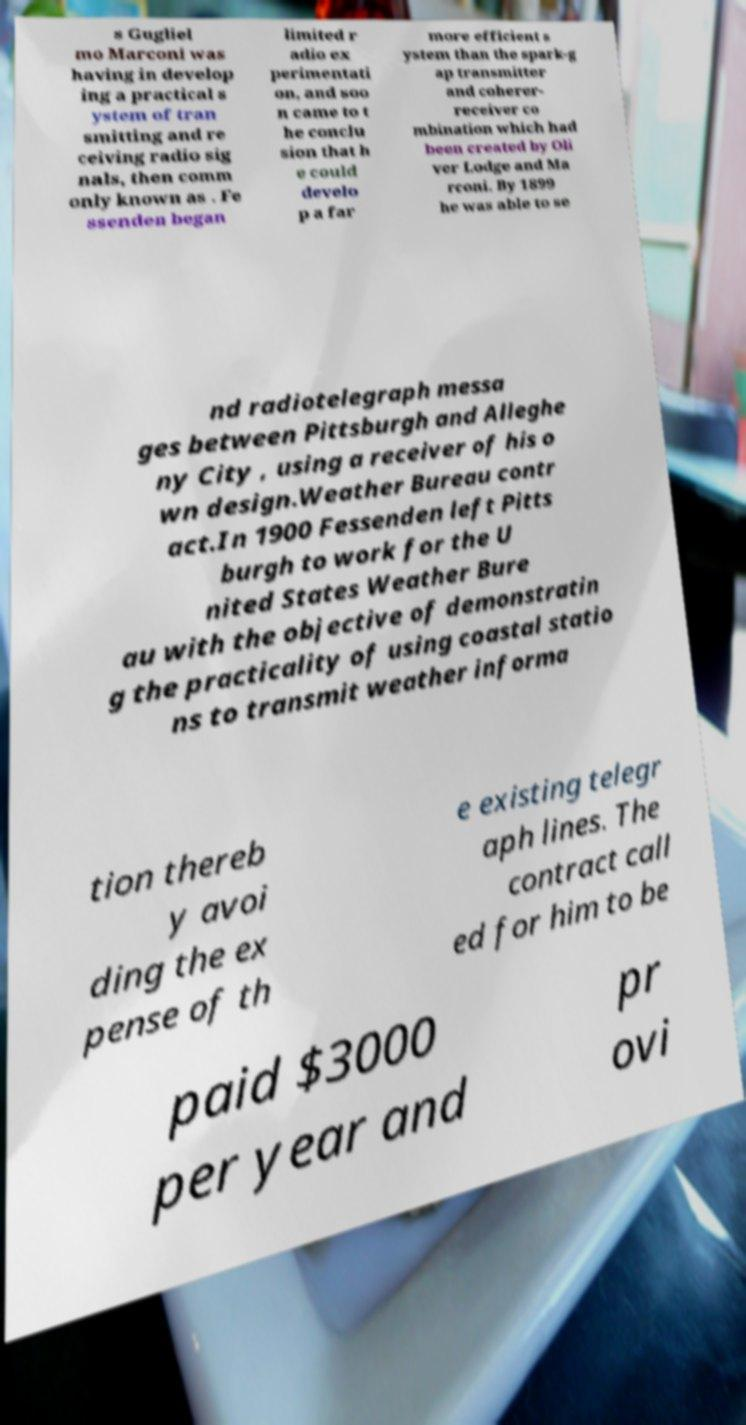I need the written content from this picture converted into text. Can you do that? s Gugliel mo Marconi was having in develop ing a practical s ystem of tran smitting and re ceiving radio sig nals, then comm only known as . Fe ssenden began limited r adio ex perimentati on, and soo n came to t he conclu sion that h e could develo p a far more efficient s ystem than the spark-g ap transmitter and coherer- receiver co mbination which had been created by Oli ver Lodge and Ma rconi. By 1899 he was able to se nd radiotelegraph messa ges between Pittsburgh and Alleghe ny City , using a receiver of his o wn design.Weather Bureau contr act.In 1900 Fessenden left Pitts burgh to work for the U nited States Weather Bure au with the objective of demonstratin g the practicality of using coastal statio ns to transmit weather informa tion thereb y avoi ding the ex pense of th e existing telegr aph lines. The contract call ed for him to be paid $3000 per year and pr ovi 